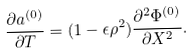<formula> <loc_0><loc_0><loc_500><loc_500>\frac { \partial a ^ { ( 0 ) } } { \partial T } = ( 1 - \epsilon \rho ^ { 2 } ) \frac { \partial ^ { 2 } \Phi ^ { ( 0 ) } } { \partial X ^ { 2 } } .</formula> 